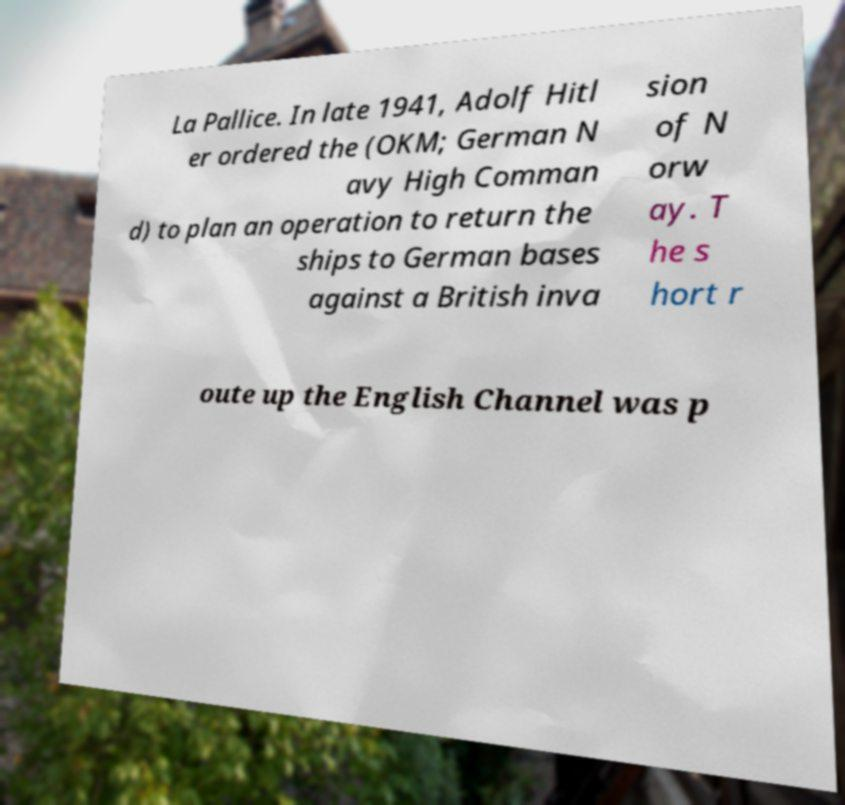Please identify and transcribe the text found in this image. La Pallice. In late 1941, Adolf Hitl er ordered the (OKM; German N avy High Comman d) to plan an operation to return the ships to German bases against a British inva sion of N orw ay. T he s hort r oute up the English Channel was p 